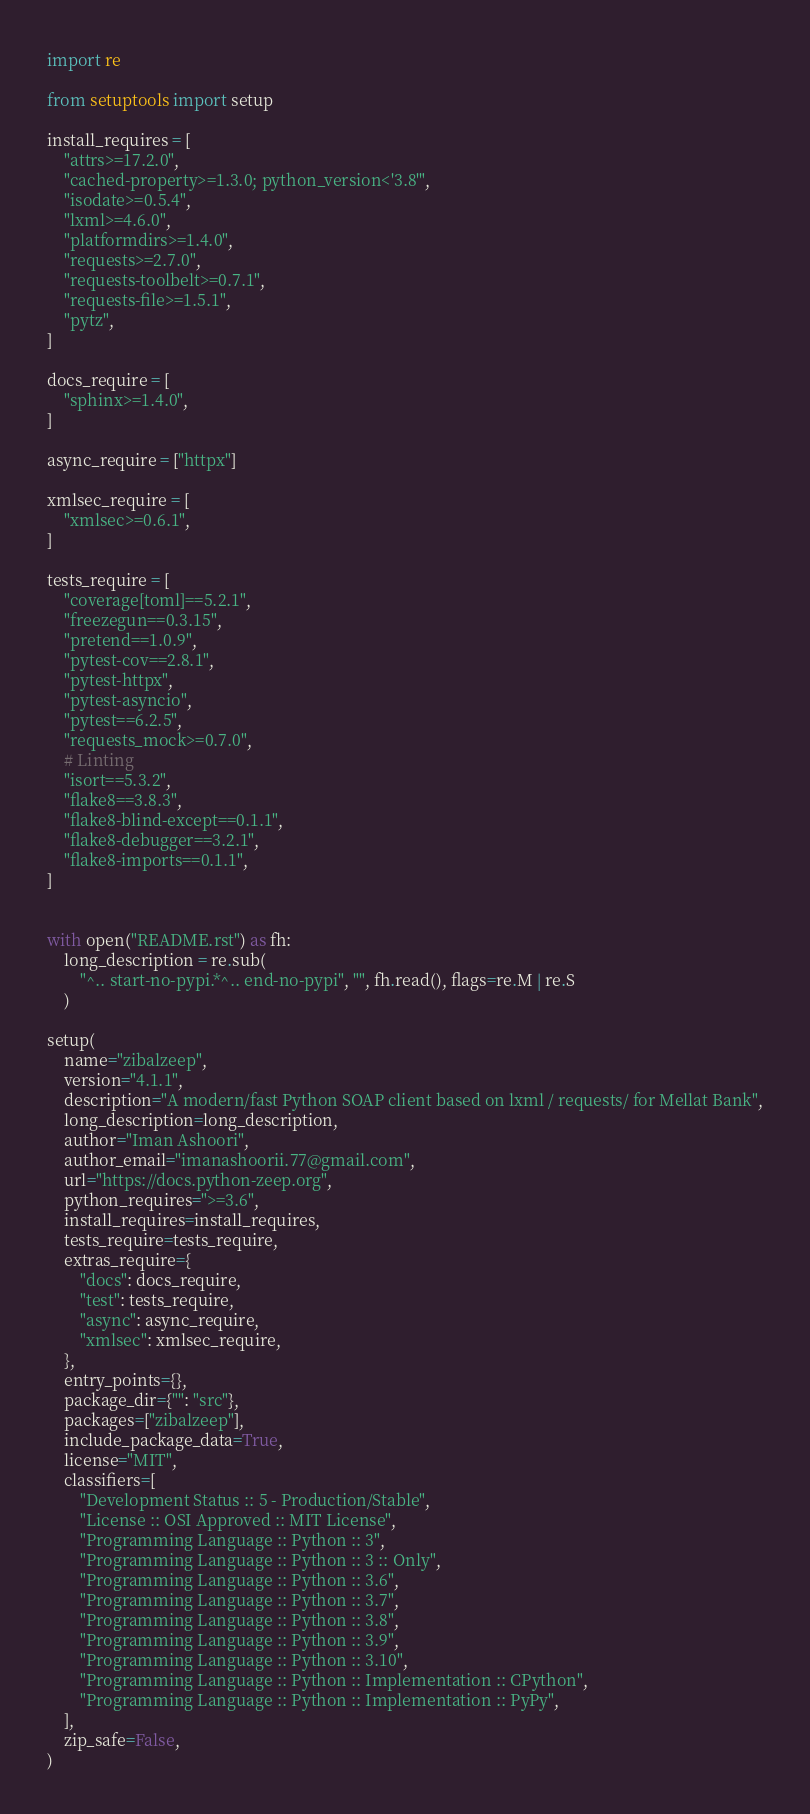Convert code to text. <code><loc_0><loc_0><loc_500><loc_500><_Python_>import re

from setuptools import setup

install_requires = [
    "attrs>=17.2.0",
    "cached-property>=1.3.0; python_version<'3.8'",
    "isodate>=0.5.4",
    "lxml>=4.6.0",
    "platformdirs>=1.4.0",
    "requests>=2.7.0",
    "requests-toolbelt>=0.7.1",
    "requests-file>=1.5.1",
    "pytz",
]

docs_require = [
    "sphinx>=1.4.0",
]

async_require = ["httpx"]

xmlsec_require = [
    "xmlsec>=0.6.1",
]

tests_require = [
    "coverage[toml]==5.2.1",
    "freezegun==0.3.15",
    "pretend==1.0.9",
    "pytest-cov==2.8.1",
    "pytest-httpx",
    "pytest-asyncio",
    "pytest==6.2.5",
    "requests_mock>=0.7.0",
    # Linting
    "isort==5.3.2",
    "flake8==3.8.3",
    "flake8-blind-except==0.1.1",
    "flake8-debugger==3.2.1",
    "flake8-imports==0.1.1",
]


with open("README.rst") as fh:
    long_description = re.sub(
        "^.. start-no-pypi.*^.. end-no-pypi", "", fh.read(), flags=re.M | re.S
    )

setup(
    name="zibalzeep",
    version="4.1.1",
    description="A modern/fast Python SOAP client based on lxml / requests/ for Mellat Bank",
    long_description=long_description,
    author="Iman Ashoori",
    author_email="imanashoorii.77@gmail.com",
    url="https://docs.python-zeep.org",
    python_requires=">=3.6",
    install_requires=install_requires,
    tests_require=tests_require,
    extras_require={
        "docs": docs_require,
        "test": tests_require,
        "async": async_require,
        "xmlsec": xmlsec_require,
    },
    entry_points={},
    package_dir={"": "src"},
    packages=["zibalzeep"],
    include_package_data=True,
    license="MIT",
    classifiers=[
        "Development Status :: 5 - Production/Stable",
        "License :: OSI Approved :: MIT License",
        "Programming Language :: Python :: 3",
        "Programming Language :: Python :: 3 :: Only",
        "Programming Language :: Python :: 3.6",
        "Programming Language :: Python :: 3.7",
        "Programming Language :: Python :: 3.8",
        "Programming Language :: Python :: 3.9",
        "Programming Language :: Python :: 3.10",
        "Programming Language :: Python :: Implementation :: CPython",
        "Programming Language :: Python :: Implementation :: PyPy",
    ],
    zip_safe=False,
)
</code> 